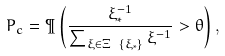<formula> <loc_0><loc_0><loc_500><loc_500>P _ { c } = \P \left ( \frac { \xi _ { \ast } ^ { - 1 } } { \sum _ { \xi \in \Xi \ \{ \xi _ { \ast } \} } \xi ^ { - 1 } } > \theta \right ) ,</formula> 